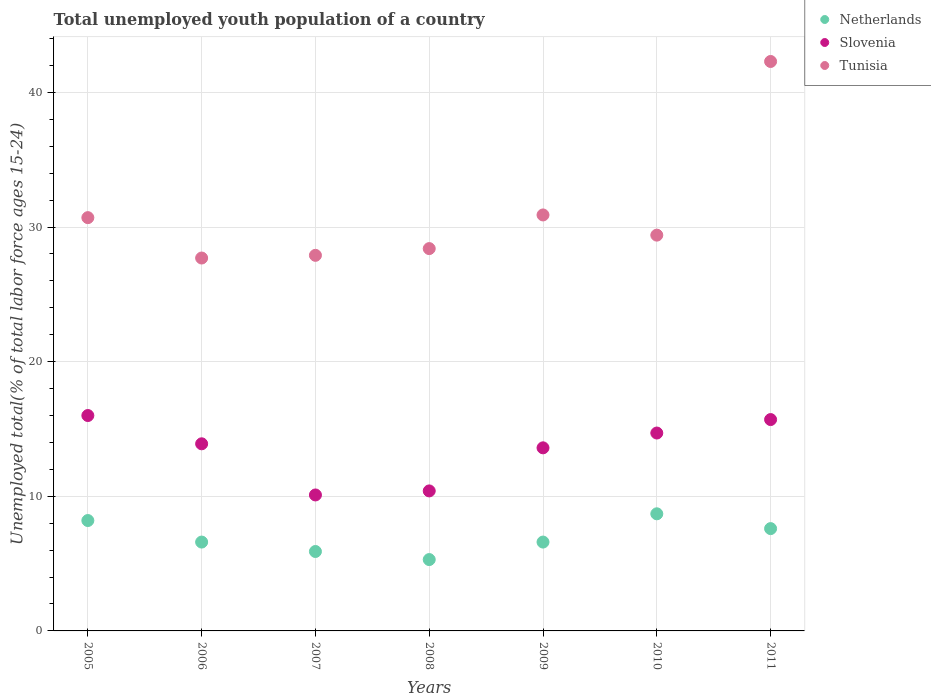How many different coloured dotlines are there?
Provide a short and direct response. 3. Is the number of dotlines equal to the number of legend labels?
Keep it short and to the point. Yes. What is the percentage of total unemployed youth population of a country in Tunisia in 2008?
Ensure brevity in your answer.  28.4. Across all years, what is the maximum percentage of total unemployed youth population of a country in Slovenia?
Provide a short and direct response. 16. Across all years, what is the minimum percentage of total unemployed youth population of a country in Slovenia?
Your answer should be very brief. 10.1. What is the total percentage of total unemployed youth population of a country in Slovenia in the graph?
Offer a terse response. 94.4. What is the difference between the percentage of total unemployed youth population of a country in Tunisia in 2006 and that in 2010?
Your answer should be very brief. -1.7. What is the difference between the percentage of total unemployed youth population of a country in Slovenia in 2008 and the percentage of total unemployed youth population of a country in Netherlands in 2010?
Provide a short and direct response. 1.7. What is the average percentage of total unemployed youth population of a country in Tunisia per year?
Provide a short and direct response. 31.04. In the year 2011, what is the difference between the percentage of total unemployed youth population of a country in Tunisia and percentage of total unemployed youth population of a country in Netherlands?
Your response must be concise. 34.7. What is the ratio of the percentage of total unemployed youth population of a country in Slovenia in 2006 to that in 2011?
Your answer should be very brief. 0.89. Is the percentage of total unemployed youth population of a country in Slovenia in 2006 less than that in 2011?
Your answer should be compact. Yes. What is the difference between the highest and the second highest percentage of total unemployed youth population of a country in Tunisia?
Keep it short and to the point. 11.4. What is the difference between the highest and the lowest percentage of total unemployed youth population of a country in Slovenia?
Keep it short and to the point. 5.9. Does the graph contain grids?
Keep it short and to the point. Yes. Where does the legend appear in the graph?
Your answer should be compact. Top right. How many legend labels are there?
Provide a short and direct response. 3. What is the title of the graph?
Offer a terse response. Total unemployed youth population of a country. Does "Poland" appear as one of the legend labels in the graph?
Ensure brevity in your answer.  No. What is the label or title of the Y-axis?
Your answer should be very brief. Unemployed total(% of total labor force ages 15-24). What is the Unemployed total(% of total labor force ages 15-24) of Netherlands in 2005?
Ensure brevity in your answer.  8.2. What is the Unemployed total(% of total labor force ages 15-24) in Tunisia in 2005?
Keep it short and to the point. 30.7. What is the Unemployed total(% of total labor force ages 15-24) of Netherlands in 2006?
Offer a terse response. 6.6. What is the Unemployed total(% of total labor force ages 15-24) of Slovenia in 2006?
Your answer should be very brief. 13.9. What is the Unemployed total(% of total labor force ages 15-24) in Tunisia in 2006?
Make the answer very short. 27.7. What is the Unemployed total(% of total labor force ages 15-24) in Netherlands in 2007?
Your answer should be compact. 5.9. What is the Unemployed total(% of total labor force ages 15-24) in Slovenia in 2007?
Offer a terse response. 10.1. What is the Unemployed total(% of total labor force ages 15-24) in Tunisia in 2007?
Give a very brief answer. 27.9. What is the Unemployed total(% of total labor force ages 15-24) in Netherlands in 2008?
Offer a terse response. 5.3. What is the Unemployed total(% of total labor force ages 15-24) of Slovenia in 2008?
Make the answer very short. 10.4. What is the Unemployed total(% of total labor force ages 15-24) in Tunisia in 2008?
Provide a short and direct response. 28.4. What is the Unemployed total(% of total labor force ages 15-24) of Netherlands in 2009?
Offer a terse response. 6.6. What is the Unemployed total(% of total labor force ages 15-24) in Slovenia in 2009?
Offer a terse response. 13.6. What is the Unemployed total(% of total labor force ages 15-24) in Tunisia in 2009?
Offer a very short reply. 30.9. What is the Unemployed total(% of total labor force ages 15-24) in Netherlands in 2010?
Your answer should be compact. 8.7. What is the Unemployed total(% of total labor force ages 15-24) in Slovenia in 2010?
Offer a terse response. 14.7. What is the Unemployed total(% of total labor force ages 15-24) in Tunisia in 2010?
Keep it short and to the point. 29.4. What is the Unemployed total(% of total labor force ages 15-24) of Netherlands in 2011?
Offer a terse response. 7.6. What is the Unemployed total(% of total labor force ages 15-24) in Slovenia in 2011?
Your answer should be compact. 15.7. What is the Unemployed total(% of total labor force ages 15-24) in Tunisia in 2011?
Make the answer very short. 42.3. Across all years, what is the maximum Unemployed total(% of total labor force ages 15-24) in Netherlands?
Provide a short and direct response. 8.7. Across all years, what is the maximum Unemployed total(% of total labor force ages 15-24) of Slovenia?
Give a very brief answer. 16. Across all years, what is the maximum Unemployed total(% of total labor force ages 15-24) of Tunisia?
Your answer should be compact. 42.3. Across all years, what is the minimum Unemployed total(% of total labor force ages 15-24) of Netherlands?
Your answer should be compact. 5.3. Across all years, what is the minimum Unemployed total(% of total labor force ages 15-24) in Slovenia?
Provide a succinct answer. 10.1. Across all years, what is the minimum Unemployed total(% of total labor force ages 15-24) in Tunisia?
Provide a short and direct response. 27.7. What is the total Unemployed total(% of total labor force ages 15-24) of Netherlands in the graph?
Provide a succinct answer. 48.9. What is the total Unemployed total(% of total labor force ages 15-24) of Slovenia in the graph?
Your response must be concise. 94.4. What is the total Unemployed total(% of total labor force ages 15-24) in Tunisia in the graph?
Provide a short and direct response. 217.3. What is the difference between the Unemployed total(% of total labor force ages 15-24) of Netherlands in 2005 and that in 2006?
Provide a short and direct response. 1.6. What is the difference between the Unemployed total(% of total labor force ages 15-24) in Netherlands in 2005 and that in 2007?
Ensure brevity in your answer.  2.3. What is the difference between the Unemployed total(% of total labor force ages 15-24) in Netherlands in 2005 and that in 2009?
Offer a very short reply. 1.6. What is the difference between the Unemployed total(% of total labor force ages 15-24) in Tunisia in 2005 and that in 2010?
Your answer should be very brief. 1.3. What is the difference between the Unemployed total(% of total labor force ages 15-24) of Netherlands in 2005 and that in 2011?
Provide a short and direct response. 0.6. What is the difference between the Unemployed total(% of total labor force ages 15-24) in Slovenia in 2005 and that in 2011?
Keep it short and to the point. 0.3. What is the difference between the Unemployed total(% of total labor force ages 15-24) of Netherlands in 2006 and that in 2007?
Give a very brief answer. 0.7. What is the difference between the Unemployed total(% of total labor force ages 15-24) in Slovenia in 2006 and that in 2007?
Your answer should be very brief. 3.8. What is the difference between the Unemployed total(% of total labor force ages 15-24) in Netherlands in 2006 and that in 2008?
Provide a short and direct response. 1.3. What is the difference between the Unemployed total(% of total labor force ages 15-24) in Slovenia in 2006 and that in 2008?
Make the answer very short. 3.5. What is the difference between the Unemployed total(% of total labor force ages 15-24) in Tunisia in 2006 and that in 2008?
Your answer should be compact. -0.7. What is the difference between the Unemployed total(% of total labor force ages 15-24) in Netherlands in 2006 and that in 2009?
Offer a very short reply. 0. What is the difference between the Unemployed total(% of total labor force ages 15-24) of Slovenia in 2006 and that in 2009?
Offer a terse response. 0.3. What is the difference between the Unemployed total(% of total labor force ages 15-24) of Netherlands in 2006 and that in 2010?
Provide a succinct answer. -2.1. What is the difference between the Unemployed total(% of total labor force ages 15-24) in Tunisia in 2006 and that in 2010?
Your answer should be very brief. -1.7. What is the difference between the Unemployed total(% of total labor force ages 15-24) of Slovenia in 2006 and that in 2011?
Your answer should be very brief. -1.8. What is the difference between the Unemployed total(% of total labor force ages 15-24) of Tunisia in 2006 and that in 2011?
Ensure brevity in your answer.  -14.6. What is the difference between the Unemployed total(% of total labor force ages 15-24) in Netherlands in 2007 and that in 2008?
Ensure brevity in your answer.  0.6. What is the difference between the Unemployed total(% of total labor force ages 15-24) of Tunisia in 2007 and that in 2008?
Ensure brevity in your answer.  -0.5. What is the difference between the Unemployed total(% of total labor force ages 15-24) of Netherlands in 2007 and that in 2010?
Keep it short and to the point. -2.8. What is the difference between the Unemployed total(% of total labor force ages 15-24) of Slovenia in 2007 and that in 2010?
Make the answer very short. -4.6. What is the difference between the Unemployed total(% of total labor force ages 15-24) of Tunisia in 2007 and that in 2010?
Provide a short and direct response. -1.5. What is the difference between the Unemployed total(% of total labor force ages 15-24) of Netherlands in 2007 and that in 2011?
Your answer should be compact. -1.7. What is the difference between the Unemployed total(% of total labor force ages 15-24) of Tunisia in 2007 and that in 2011?
Your answer should be compact. -14.4. What is the difference between the Unemployed total(% of total labor force ages 15-24) of Netherlands in 2008 and that in 2009?
Provide a succinct answer. -1.3. What is the difference between the Unemployed total(% of total labor force ages 15-24) of Slovenia in 2008 and that in 2009?
Your response must be concise. -3.2. What is the difference between the Unemployed total(% of total labor force ages 15-24) in Tunisia in 2008 and that in 2009?
Offer a terse response. -2.5. What is the difference between the Unemployed total(% of total labor force ages 15-24) of Netherlands in 2008 and that in 2010?
Make the answer very short. -3.4. What is the difference between the Unemployed total(% of total labor force ages 15-24) in Slovenia in 2008 and that in 2010?
Your answer should be very brief. -4.3. What is the difference between the Unemployed total(% of total labor force ages 15-24) of Tunisia in 2008 and that in 2010?
Your answer should be compact. -1. What is the difference between the Unemployed total(% of total labor force ages 15-24) in Tunisia in 2008 and that in 2011?
Provide a succinct answer. -13.9. What is the difference between the Unemployed total(% of total labor force ages 15-24) in Tunisia in 2009 and that in 2010?
Your answer should be compact. 1.5. What is the difference between the Unemployed total(% of total labor force ages 15-24) in Netherlands in 2009 and that in 2011?
Make the answer very short. -1. What is the difference between the Unemployed total(% of total labor force ages 15-24) of Slovenia in 2009 and that in 2011?
Offer a terse response. -2.1. What is the difference between the Unemployed total(% of total labor force ages 15-24) in Netherlands in 2010 and that in 2011?
Ensure brevity in your answer.  1.1. What is the difference between the Unemployed total(% of total labor force ages 15-24) in Slovenia in 2010 and that in 2011?
Give a very brief answer. -1. What is the difference between the Unemployed total(% of total labor force ages 15-24) of Netherlands in 2005 and the Unemployed total(% of total labor force ages 15-24) of Slovenia in 2006?
Make the answer very short. -5.7. What is the difference between the Unemployed total(% of total labor force ages 15-24) in Netherlands in 2005 and the Unemployed total(% of total labor force ages 15-24) in Tunisia in 2006?
Keep it short and to the point. -19.5. What is the difference between the Unemployed total(% of total labor force ages 15-24) of Slovenia in 2005 and the Unemployed total(% of total labor force ages 15-24) of Tunisia in 2006?
Your response must be concise. -11.7. What is the difference between the Unemployed total(% of total labor force ages 15-24) of Netherlands in 2005 and the Unemployed total(% of total labor force ages 15-24) of Slovenia in 2007?
Ensure brevity in your answer.  -1.9. What is the difference between the Unemployed total(% of total labor force ages 15-24) of Netherlands in 2005 and the Unemployed total(% of total labor force ages 15-24) of Tunisia in 2007?
Offer a terse response. -19.7. What is the difference between the Unemployed total(% of total labor force ages 15-24) in Slovenia in 2005 and the Unemployed total(% of total labor force ages 15-24) in Tunisia in 2007?
Provide a succinct answer. -11.9. What is the difference between the Unemployed total(% of total labor force ages 15-24) of Netherlands in 2005 and the Unemployed total(% of total labor force ages 15-24) of Tunisia in 2008?
Provide a succinct answer. -20.2. What is the difference between the Unemployed total(% of total labor force ages 15-24) in Slovenia in 2005 and the Unemployed total(% of total labor force ages 15-24) in Tunisia in 2008?
Provide a succinct answer. -12.4. What is the difference between the Unemployed total(% of total labor force ages 15-24) of Netherlands in 2005 and the Unemployed total(% of total labor force ages 15-24) of Tunisia in 2009?
Your answer should be very brief. -22.7. What is the difference between the Unemployed total(% of total labor force ages 15-24) of Slovenia in 2005 and the Unemployed total(% of total labor force ages 15-24) of Tunisia in 2009?
Give a very brief answer. -14.9. What is the difference between the Unemployed total(% of total labor force ages 15-24) in Netherlands in 2005 and the Unemployed total(% of total labor force ages 15-24) in Tunisia in 2010?
Ensure brevity in your answer.  -21.2. What is the difference between the Unemployed total(% of total labor force ages 15-24) in Slovenia in 2005 and the Unemployed total(% of total labor force ages 15-24) in Tunisia in 2010?
Make the answer very short. -13.4. What is the difference between the Unemployed total(% of total labor force ages 15-24) of Netherlands in 2005 and the Unemployed total(% of total labor force ages 15-24) of Tunisia in 2011?
Give a very brief answer. -34.1. What is the difference between the Unemployed total(% of total labor force ages 15-24) in Slovenia in 2005 and the Unemployed total(% of total labor force ages 15-24) in Tunisia in 2011?
Keep it short and to the point. -26.3. What is the difference between the Unemployed total(% of total labor force ages 15-24) of Netherlands in 2006 and the Unemployed total(% of total labor force ages 15-24) of Tunisia in 2007?
Offer a terse response. -21.3. What is the difference between the Unemployed total(% of total labor force ages 15-24) of Slovenia in 2006 and the Unemployed total(% of total labor force ages 15-24) of Tunisia in 2007?
Offer a very short reply. -14. What is the difference between the Unemployed total(% of total labor force ages 15-24) of Netherlands in 2006 and the Unemployed total(% of total labor force ages 15-24) of Slovenia in 2008?
Offer a very short reply. -3.8. What is the difference between the Unemployed total(% of total labor force ages 15-24) of Netherlands in 2006 and the Unemployed total(% of total labor force ages 15-24) of Tunisia in 2008?
Your response must be concise. -21.8. What is the difference between the Unemployed total(% of total labor force ages 15-24) of Netherlands in 2006 and the Unemployed total(% of total labor force ages 15-24) of Slovenia in 2009?
Make the answer very short. -7. What is the difference between the Unemployed total(% of total labor force ages 15-24) in Netherlands in 2006 and the Unemployed total(% of total labor force ages 15-24) in Tunisia in 2009?
Make the answer very short. -24.3. What is the difference between the Unemployed total(% of total labor force ages 15-24) in Netherlands in 2006 and the Unemployed total(% of total labor force ages 15-24) in Tunisia in 2010?
Provide a succinct answer. -22.8. What is the difference between the Unemployed total(% of total labor force ages 15-24) in Slovenia in 2006 and the Unemployed total(% of total labor force ages 15-24) in Tunisia in 2010?
Provide a succinct answer. -15.5. What is the difference between the Unemployed total(% of total labor force ages 15-24) in Netherlands in 2006 and the Unemployed total(% of total labor force ages 15-24) in Tunisia in 2011?
Make the answer very short. -35.7. What is the difference between the Unemployed total(% of total labor force ages 15-24) in Slovenia in 2006 and the Unemployed total(% of total labor force ages 15-24) in Tunisia in 2011?
Provide a short and direct response. -28.4. What is the difference between the Unemployed total(% of total labor force ages 15-24) of Netherlands in 2007 and the Unemployed total(% of total labor force ages 15-24) of Tunisia in 2008?
Make the answer very short. -22.5. What is the difference between the Unemployed total(% of total labor force ages 15-24) in Slovenia in 2007 and the Unemployed total(% of total labor force ages 15-24) in Tunisia in 2008?
Give a very brief answer. -18.3. What is the difference between the Unemployed total(% of total labor force ages 15-24) of Netherlands in 2007 and the Unemployed total(% of total labor force ages 15-24) of Slovenia in 2009?
Your answer should be compact. -7.7. What is the difference between the Unemployed total(% of total labor force ages 15-24) of Slovenia in 2007 and the Unemployed total(% of total labor force ages 15-24) of Tunisia in 2009?
Make the answer very short. -20.8. What is the difference between the Unemployed total(% of total labor force ages 15-24) in Netherlands in 2007 and the Unemployed total(% of total labor force ages 15-24) in Tunisia in 2010?
Ensure brevity in your answer.  -23.5. What is the difference between the Unemployed total(% of total labor force ages 15-24) in Slovenia in 2007 and the Unemployed total(% of total labor force ages 15-24) in Tunisia in 2010?
Offer a very short reply. -19.3. What is the difference between the Unemployed total(% of total labor force ages 15-24) in Netherlands in 2007 and the Unemployed total(% of total labor force ages 15-24) in Slovenia in 2011?
Offer a terse response. -9.8. What is the difference between the Unemployed total(% of total labor force ages 15-24) in Netherlands in 2007 and the Unemployed total(% of total labor force ages 15-24) in Tunisia in 2011?
Keep it short and to the point. -36.4. What is the difference between the Unemployed total(% of total labor force ages 15-24) in Slovenia in 2007 and the Unemployed total(% of total labor force ages 15-24) in Tunisia in 2011?
Provide a short and direct response. -32.2. What is the difference between the Unemployed total(% of total labor force ages 15-24) in Netherlands in 2008 and the Unemployed total(% of total labor force ages 15-24) in Tunisia in 2009?
Ensure brevity in your answer.  -25.6. What is the difference between the Unemployed total(% of total labor force ages 15-24) in Slovenia in 2008 and the Unemployed total(% of total labor force ages 15-24) in Tunisia in 2009?
Make the answer very short. -20.5. What is the difference between the Unemployed total(% of total labor force ages 15-24) in Netherlands in 2008 and the Unemployed total(% of total labor force ages 15-24) in Slovenia in 2010?
Offer a very short reply. -9.4. What is the difference between the Unemployed total(% of total labor force ages 15-24) of Netherlands in 2008 and the Unemployed total(% of total labor force ages 15-24) of Tunisia in 2010?
Your answer should be compact. -24.1. What is the difference between the Unemployed total(% of total labor force ages 15-24) of Netherlands in 2008 and the Unemployed total(% of total labor force ages 15-24) of Slovenia in 2011?
Give a very brief answer. -10.4. What is the difference between the Unemployed total(% of total labor force ages 15-24) in Netherlands in 2008 and the Unemployed total(% of total labor force ages 15-24) in Tunisia in 2011?
Offer a very short reply. -37. What is the difference between the Unemployed total(% of total labor force ages 15-24) in Slovenia in 2008 and the Unemployed total(% of total labor force ages 15-24) in Tunisia in 2011?
Give a very brief answer. -31.9. What is the difference between the Unemployed total(% of total labor force ages 15-24) in Netherlands in 2009 and the Unemployed total(% of total labor force ages 15-24) in Slovenia in 2010?
Provide a short and direct response. -8.1. What is the difference between the Unemployed total(% of total labor force ages 15-24) of Netherlands in 2009 and the Unemployed total(% of total labor force ages 15-24) of Tunisia in 2010?
Offer a very short reply. -22.8. What is the difference between the Unemployed total(% of total labor force ages 15-24) of Slovenia in 2009 and the Unemployed total(% of total labor force ages 15-24) of Tunisia in 2010?
Offer a very short reply. -15.8. What is the difference between the Unemployed total(% of total labor force ages 15-24) in Netherlands in 2009 and the Unemployed total(% of total labor force ages 15-24) in Tunisia in 2011?
Make the answer very short. -35.7. What is the difference between the Unemployed total(% of total labor force ages 15-24) of Slovenia in 2009 and the Unemployed total(% of total labor force ages 15-24) of Tunisia in 2011?
Provide a succinct answer. -28.7. What is the difference between the Unemployed total(% of total labor force ages 15-24) of Netherlands in 2010 and the Unemployed total(% of total labor force ages 15-24) of Slovenia in 2011?
Provide a short and direct response. -7. What is the difference between the Unemployed total(% of total labor force ages 15-24) of Netherlands in 2010 and the Unemployed total(% of total labor force ages 15-24) of Tunisia in 2011?
Make the answer very short. -33.6. What is the difference between the Unemployed total(% of total labor force ages 15-24) of Slovenia in 2010 and the Unemployed total(% of total labor force ages 15-24) of Tunisia in 2011?
Your response must be concise. -27.6. What is the average Unemployed total(% of total labor force ages 15-24) of Netherlands per year?
Your answer should be very brief. 6.99. What is the average Unemployed total(% of total labor force ages 15-24) of Slovenia per year?
Give a very brief answer. 13.49. What is the average Unemployed total(% of total labor force ages 15-24) of Tunisia per year?
Keep it short and to the point. 31.04. In the year 2005, what is the difference between the Unemployed total(% of total labor force ages 15-24) of Netherlands and Unemployed total(% of total labor force ages 15-24) of Slovenia?
Your answer should be very brief. -7.8. In the year 2005, what is the difference between the Unemployed total(% of total labor force ages 15-24) in Netherlands and Unemployed total(% of total labor force ages 15-24) in Tunisia?
Offer a very short reply. -22.5. In the year 2005, what is the difference between the Unemployed total(% of total labor force ages 15-24) of Slovenia and Unemployed total(% of total labor force ages 15-24) of Tunisia?
Give a very brief answer. -14.7. In the year 2006, what is the difference between the Unemployed total(% of total labor force ages 15-24) of Netherlands and Unemployed total(% of total labor force ages 15-24) of Tunisia?
Your response must be concise. -21.1. In the year 2007, what is the difference between the Unemployed total(% of total labor force ages 15-24) of Netherlands and Unemployed total(% of total labor force ages 15-24) of Slovenia?
Offer a terse response. -4.2. In the year 2007, what is the difference between the Unemployed total(% of total labor force ages 15-24) in Slovenia and Unemployed total(% of total labor force ages 15-24) in Tunisia?
Ensure brevity in your answer.  -17.8. In the year 2008, what is the difference between the Unemployed total(% of total labor force ages 15-24) of Netherlands and Unemployed total(% of total labor force ages 15-24) of Slovenia?
Make the answer very short. -5.1. In the year 2008, what is the difference between the Unemployed total(% of total labor force ages 15-24) in Netherlands and Unemployed total(% of total labor force ages 15-24) in Tunisia?
Your answer should be very brief. -23.1. In the year 2009, what is the difference between the Unemployed total(% of total labor force ages 15-24) of Netherlands and Unemployed total(% of total labor force ages 15-24) of Tunisia?
Ensure brevity in your answer.  -24.3. In the year 2009, what is the difference between the Unemployed total(% of total labor force ages 15-24) of Slovenia and Unemployed total(% of total labor force ages 15-24) of Tunisia?
Your response must be concise. -17.3. In the year 2010, what is the difference between the Unemployed total(% of total labor force ages 15-24) of Netherlands and Unemployed total(% of total labor force ages 15-24) of Slovenia?
Provide a short and direct response. -6. In the year 2010, what is the difference between the Unemployed total(% of total labor force ages 15-24) of Netherlands and Unemployed total(% of total labor force ages 15-24) of Tunisia?
Give a very brief answer. -20.7. In the year 2010, what is the difference between the Unemployed total(% of total labor force ages 15-24) in Slovenia and Unemployed total(% of total labor force ages 15-24) in Tunisia?
Your response must be concise. -14.7. In the year 2011, what is the difference between the Unemployed total(% of total labor force ages 15-24) of Netherlands and Unemployed total(% of total labor force ages 15-24) of Slovenia?
Keep it short and to the point. -8.1. In the year 2011, what is the difference between the Unemployed total(% of total labor force ages 15-24) of Netherlands and Unemployed total(% of total labor force ages 15-24) of Tunisia?
Offer a terse response. -34.7. In the year 2011, what is the difference between the Unemployed total(% of total labor force ages 15-24) in Slovenia and Unemployed total(% of total labor force ages 15-24) in Tunisia?
Make the answer very short. -26.6. What is the ratio of the Unemployed total(% of total labor force ages 15-24) of Netherlands in 2005 to that in 2006?
Your response must be concise. 1.24. What is the ratio of the Unemployed total(% of total labor force ages 15-24) in Slovenia in 2005 to that in 2006?
Provide a succinct answer. 1.15. What is the ratio of the Unemployed total(% of total labor force ages 15-24) of Tunisia in 2005 to that in 2006?
Your response must be concise. 1.11. What is the ratio of the Unemployed total(% of total labor force ages 15-24) of Netherlands in 2005 to that in 2007?
Your answer should be very brief. 1.39. What is the ratio of the Unemployed total(% of total labor force ages 15-24) of Slovenia in 2005 to that in 2007?
Ensure brevity in your answer.  1.58. What is the ratio of the Unemployed total(% of total labor force ages 15-24) of Tunisia in 2005 to that in 2007?
Offer a very short reply. 1.1. What is the ratio of the Unemployed total(% of total labor force ages 15-24) in Netherlands in 2005 to that in 2008?
Provide a succinct answer. 1.55. What is the ratio of the Unemployed total(% of total labor force ages 15-24) in Slovenia in 2005 to that in 2008?
Offer a very short reply. 1.54. What is the ratio of the Unemployed total(% of total labor force ages 15-24) in Tunisia in 2005 to that in 2008?
Provide a succinct answer. 1.08. What is the ratio of the Unemployed total(% of total labor force ages 15-24) of Netherlands in 2005 to that in 2009?
Provide a succinct answer. 1.24. What is the ratio of the Unemployed total(% of total labor force ages 15-24) of Slovenia in 2005 to that in 2009?
Your answer should be very brief. 1.18. What is the ratio of the Unemployed total(% of total labor force ages 15-24) of Netherlands in 2005 to that in 2010?
Your response must be concise. 0.94. What is the ratio of the Unemployed total(% of total labor force ages 15-24) of Slovenia in 2005 to that in 2010?
Make the answer very short. 1.09. What is the ratio of the Unemployed total(% of total labor force ages 15-24) in Tunisia in 2005 to that in 2010?
Your answer should be very brief. 1.04. What is the ratio of the Unemployed total(% of total labor force ages 15-24) in Netherlands in 2005 to that in 2011?
Keep it short and to the point. 1.08. What is the ratio of the Unemployed total(% of total labor force ages 15-24) in Slovenia in 2005 to that in 2011?
Offer a very short reply. 1.02. What is the ratio of the Unemployed total(% of total labor force ages 15-24) in Tunisia in 2005 to that in 2011?
Keep it short and to the point. 0.73. What is the ratio of the Unemployed total(% of total labor force ages 15-24) in Netherlands in 2006 to that in 2007?
Your response must be concise. 1.12. What is the ratio of the Unemployed total(% of total labor force ages 15-24) in Slovenia in 2006 to that in 2007?
Make the answer very short. 1.38. What is the ratio of the Unemployed total(% of total labor force ages 15-24) in Tunisia in 2006 to that in 2007?
Ensure brevity in your answer.  0.99. What is the ratio of the Unemployed total(% of total labor force ages 15-24) in Netherlands in 2006 to that in 2008?
Make the answer very short. 1.25. What is the ratio of the Unemployed total(% of total labor force ages 15-24) of Slovenia in 2006 to that in 2008?
Make the answer very short. 1.34. What is the ratio of the Unemployed total(% of total labor force ages 15-24) of Tunisia in 2006 to that in 2008?
Your answer should be compact. 0.98. What is the ratio of the Unemployed total(% of total labor force ages 15-24) in Netherlands in 2006 to that in 2009?
Your response must be concise. 1. What is the ratio of the Unemployed total(% of total labor force ages 15-24) in Slovenia in 2006 to that in 2009?
Make the answer very short. 1.02. What is the ratio of the Unemployed total(% of total labor force ages 15-24) in Tunisia in 2006 to that in 2009?
Give a very brief answer. 0.9. What is the ratio of the Unemployed total(% of total labor force ages 15-24) of Netherlands in 2006 to that in 2010?
Your answer should be compact. 0.76. What is the ratio of the Unemployed total(% of total labor force ages 15-24) in Slovenia in 2006 to that in 2010?
Your answer should be compact. 0.95. What is the ratio of the Unemployed total(% of total labor force ages 15-24) of Tunisia in 2006 to that in 2010?
Provide a short and direct response. 0.94. What is the ratio of the Unemployed total(% of total labor force ages 15-24) of Netherlands in 2006 to that in 2011?
Make the answer very short. 0.87. What is the ratio of the Unemployed total(% of total labor force ages 15-24) of Slovenia in 2006 to that in 2011?
Your answer should be compact. 0.89. What is the ratio of the Unemployed total(% of total labor force ages 15-24) in Tunisia in 2006 to that in 2011?
Keep it short and to the point. 0.65. What is the ratio of the Unemployed total(% of total labor force ages 15-24) in Netherlands in 2007 to that in 2008?
Ensure brevity in your answer.  1.11. What is the ratio of the Unemployed total(% of total labor force ages 15-24) of Slovenia in 2007 to that in 2008?
Provide a short and direct response. 0.97. What is the ratio of the Unemployed total(% of total labor force ages 15-24) of Tunisia in 2007 to that in 2008?
Make the answer very short. 0.98. What is the ratio of the Unemployed total(% of total labor force ages 15-24) of Netherlands in 2007 to that in 2009?
Provide a short and direct response. 0.89. What is the ratio of the Unemployed total(% of total labor force ages 15-24) of Slovenia in 2007 to that in 2009?
Provide a short and direct response. 0.74. What is the ratio of the Unemployed total(% of total labor force ages 15-24) in Tunisia in 2007 to that in 2009?
Provide a short and direct response. 0.9. What is the ratio of the Unemployed total(% of total labor force ages 15-24) in Netherlands in 2007 to that in 2010?
Provide a short and direct response. 0.68. What is the ratio of the Unemployed total(% of total labor force ages 15-24) of Slovenia in 2007 to that in 2010?
Offer a very short reply. 0.69. What is the ratio of the Unemployed total(% of total labor force ages 15-24) of Tunisia in 2007 to that in 2010?
Offer a very short reply. 0.95. What is the ratio of the Unemployed total(% of total labor force ages 15-24) in Netherlands in 2007 to that in 2011?
Your response must be concise. 0.78. What is the ratio of the Unemployed total(% of total labor force ages 15-24) of Slovenia in 2007 to that in 2011?
Offer a terse response. 0.64. What is the ratio of the Unemployed total(% of total labor force ages 15-24) in Tunisia in 2007 to that in 2011?
Your answer should be compact. 0.66. What is the ratio of the Unemployed total(% of total labor force ages 15-24) in Netherlands in 2008 to that in 2009?
Provide a succinct answer. 0.8. What is the ratio of the Unemployed total(% of total labor force ages 15-24) of Slovenia in 2008 to that in 2009?
Give a very brief answer. 0.76. What is the ratio of the Unemployed total(% of total labor force ages 15-24) of Tunisia in 2008 to that in 2009?
Provide a succinct answer. 0.92. What is the ratio of the Unemployed total(% of total labor force ages 15-24) of Netherlands in 2008 to that in 2010?
Provide a succinct answer. 0.61. What is the ratio of the Unemployed total(% of total labor force ages 15-24) of Slovenia in 2008 to that in 2010?
Provide a short and direct response. 0.71. What is the ratio of the Unemployed total(% of total labor force ages 15-24) of Tunisia in 2008 to that in 2010?
Offer a very short reply. 0.97. What is the ratio of the Unemployed total(% of total labor force ages 15-24) of Netherlands in 2008 to that in 2011?
Ensure brevity in your answer.  0.7. What is the ratio of the Unemployed total(% of total labor force ages 15-24) of Slovenia in 2008 to that in 2011?
Offer a very short reply. 0.66. What is the ratio of the Unemployed total(% of total labor force ages 15-24) in Tunisia in 2008 to that in 2011?
Offer a very short reply. 0.67. What is the ratio of the Unemployed total(% of total labor force ages 15-24) in Netherlands in 2009 to that in 2010?
Offer a terse response. 0.76. What is the ratio of the Unemployed total(% of total labor force ages 15-24) of Slovenia in 2009 to that in 2010?
Keep it short and to the point. 0.93. What is the ratio of the Unemployed total(% of total labor force ages 15-24) in Tunisia in 2009 to that in 2010?
Ensure brevity in your answer.  1.05. What is the ratio of the Unemployed total(% of total labor force ages 15-24) in Netherlands in 2009 to that in 2011?
Offer a terse response. 0.87. What is the ratio of the Unemployed total(% of total labor force ages 15-24) in Slovenia in 2009 to that in 2011?
Provide a succinct answer. 0.87. What is the ratio of the Unemployed total(% of total labor force ages 15-24) of Tunisia in 2009 to that in 2011?
Provide a short and direct response. 0.73. What is the ratio of the Unemployed total(% of total labor force ages 15-24) of Netherlands in 2010 to that in 2011?
Offer a very short reply. 1.14. What is the ratio of the Unemployed total(% of total labor force ages 15-24) of Slovenia in 2010 to that in 2011?
Make the answer very short. 0.94. What is the ratio of the Unemployed total(% of total labor force ages 15-24) in Tunisia in 2010 to that in 2011?
Your response must be concise. 0.69. What is the difference between the highest and the second highest Unemployed total(% of total labor force ages 15-24) of Slovenia?
Offer a very short reply. 0.3. What is the difference between the highest and the lowest Unemployed total(% of total labor force ages 15-24) of Netherlands?
Ensure brevity in your answer.  3.4. What is the difference between the highest and the lowest Unemployed total(% of total labor force ages 15-24) in Slovenia?
Your answer should be compact. 5.9. 